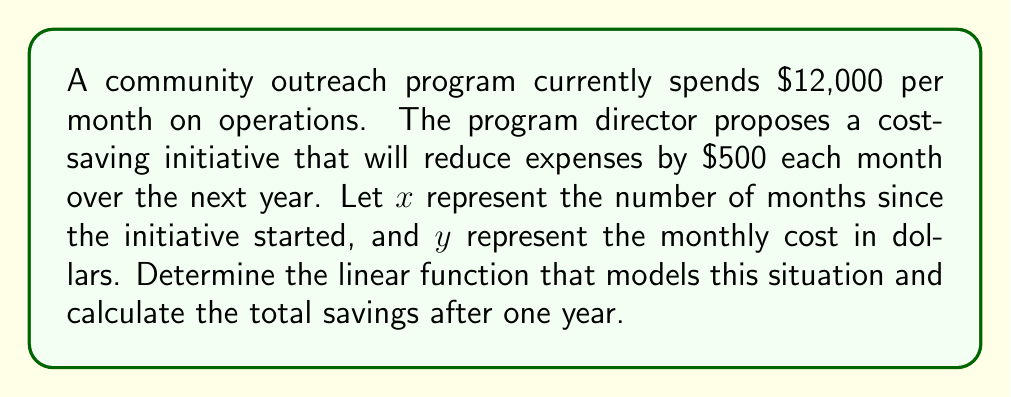Show me your answer to this math problem. 1. Identify the initial value and rate of change:
   - Initial value (y-intercept): $12,000
   - Rate of change (slope): -$500 per month

2. Write the linear function in slope-intercept form:
   $y = mx + b$, where $m$ is the slope and $b$ is the y-intercept
   $y = -500x + 12000$

3. To calculate total savings after one year:
   a. Calculate the cost at the end of 12 months:
      $y = -500(12) + 12000 = 6000$

   b. Calculate the difference between initial and final monthly costs:
      $12000 - 6000 = 6000$

   c. Calculate the total savings over 12 months:
      The savings increase linearly from $0 to $6000, so we can use the average:
      $\text{Average monthly savings} = \frac{0 + 6000}{2} = 3000$
      $\text{Total savings} = 3000 \times 12 = 36000$

Therefore, the total savings after one year is $36,000.
Answer: $y = -500x + 12000$; $36,000 